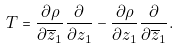Convert formula to latex. <formula><loc_0><loc_0><loc_500><loc_500>T = \frac { \partial \rho } { \partial \overline { z } _ { 1 } } \frac { \partial } { \partial z _ { 1 } } - \frac { \partial \rho } { \partial z _ { 1 } } \frac { \partial } { \partial \overline { z } _ { 1 } } .</formula> 